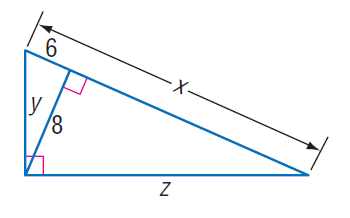Answer the mathemtical geometry problem and directly provide the correct option letter.
Question: Find y.
Choices: A: 2 \sqrt { 7 } B: 6 C: 8 D: 10 D 